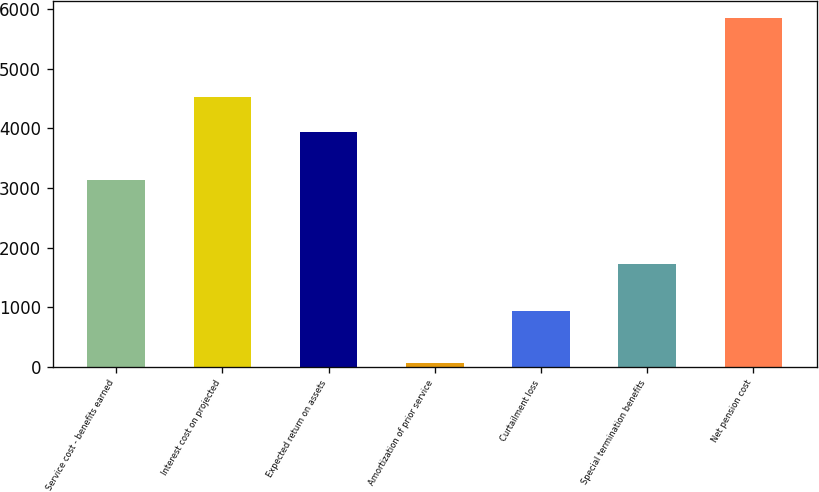<chart> <loc_0><loc_0><loc_500><loc_500><bar_chart><fcel>Service cost - benefits earned<fcel>Interest cost on projected<fcel>Expected return on assets<fcel>Amortization of prior service<fcel>Curtailment loss<fcel>Special termination benefits<fcel>Net pension cost<nl><fcel>3142<fcel>4521<fcel>3944<fcel>73<fcel>944<fcel>1720<fcel>5843<nl></chart> 